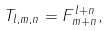<formula> <loc_0><loc_0><loc_500><loc_500>T _ { l , m , n } = F ^ { l + n } _ { m + n } ,</formula> 